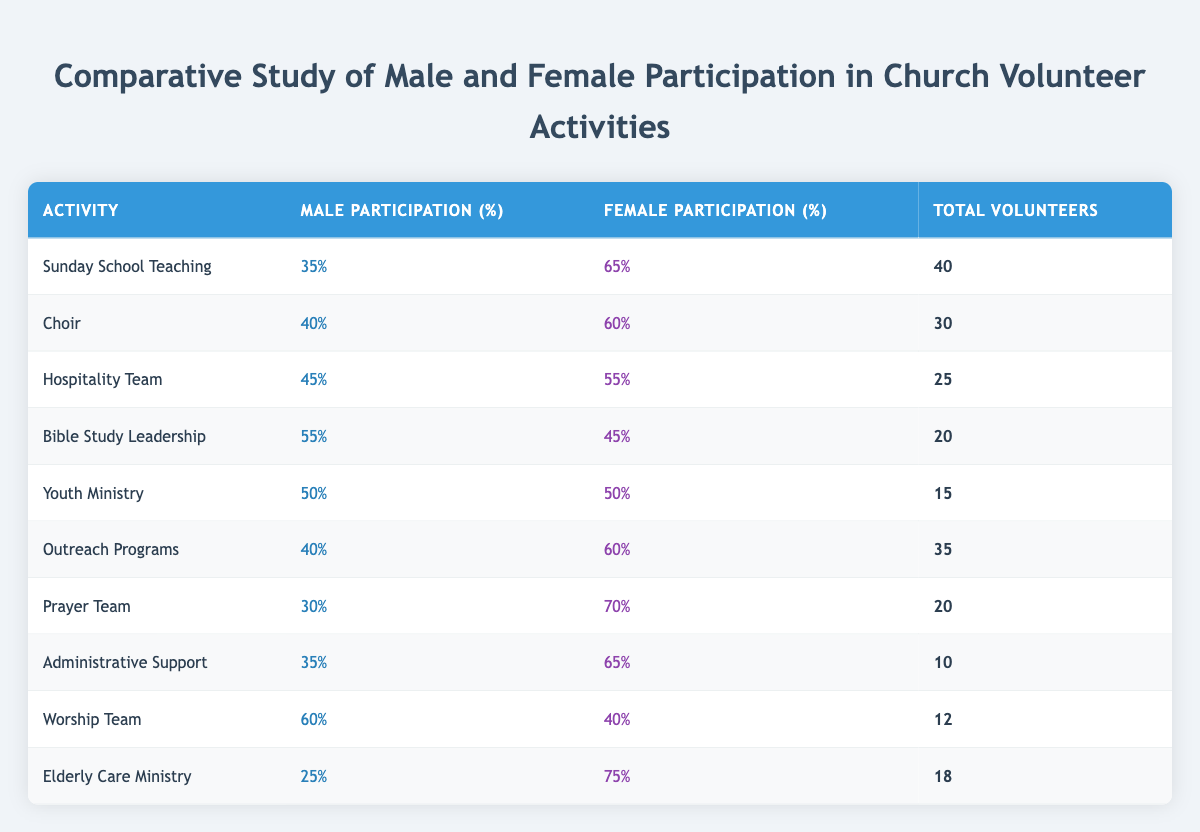What is the female participation percentage in the Elderly Care Ministry? The table lists the female participation percentage for the Elderly Care Ministry as 75%.
Answer: 75% Which activity has the highest male participation? The Worship Team has the highest male participation at 60%.
Answer: Worship Team What is the total number of volunteers for Bible Study Leadership? The table indicates that there are 20 total volunteers for Bible Study Leadership.
Answer: 20 What is the average female participation percentage across all activities? To find the average, we sum the female participation percentages (65 + 60 + 55 + 45 + 50 + 60 + 70 + 65 + 40 + 75 =  675) and divide by 10 (675/10 = 67.5). Thus, the average female participation is 67.5%.
Answer: 67.5% True or False: More than half of the volunteers in Choir are male. The table shows that the male participation in Choir is 40%, which does not exceed half (50%). Therefore, the statement is false.
Answer: False What is the difference in male participation between Sunday School Teaching and Outreach Programs? For Sunday School Teaching, male participation is 35%, while for Outreach Programs, it is 40%. The difference is calculated as 40 - 35 = 5%.
Answer: 5% Which activity has the closest male and female participation rates? The Youth Ministry has the closest participation rates, with both males and females at 50%.
Answer: Youth Ministry How many total volunteers are involved in activities where female participation is greater than 60%? The activities with female participation greater than 60% are Sunday School Teaching (40), Choir (30), Outreach Programs (35), Prayer Team (20), Administrative Support (10), and Elderly Care Ministry (18). Adding these gives (40 + 30 + 35 + 20 + 10 + 18 = 153).
Answer: 153 What percentage of the total volunteers in Bible Study Leadership are female? In Bible Study Leadership, female participation is 45%. Given the total volunteers are 20, the calculation for female volunteers is (45% of 20 = 0.45 * 20 = 9). Therefore, 9 out of 20 are female, which means 9/20 * 100% = 45%.
Answer: 45% 